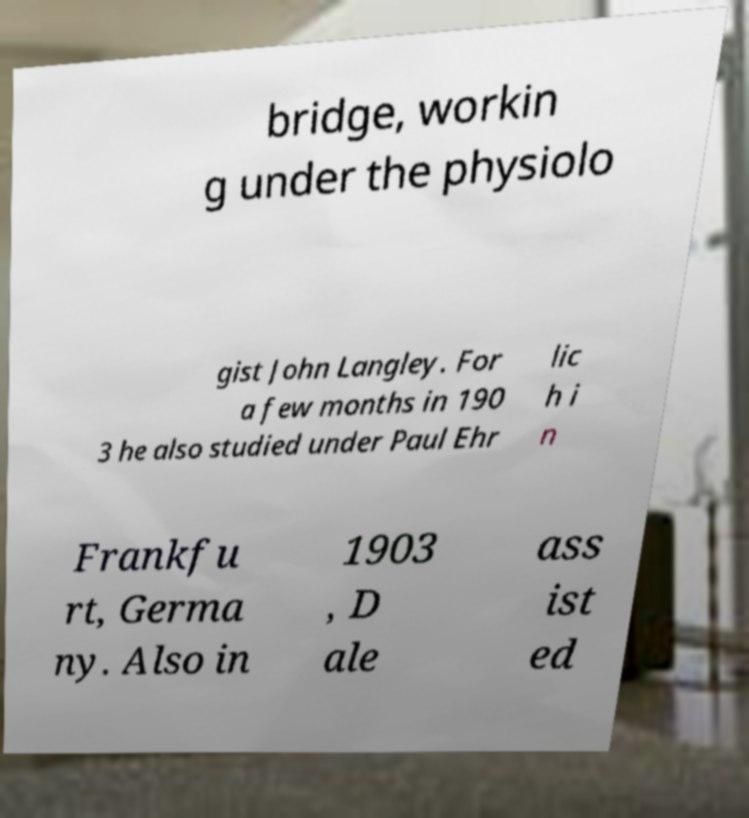Could you extract and type out the text from this image? bridge, workin g under the physiolo gist John Langley. For a few months in 190 3 he also studied under Paul Ehr lic h i n Frankfu rt, Germa ny. Also in 1903 , D ale ass ist ed 